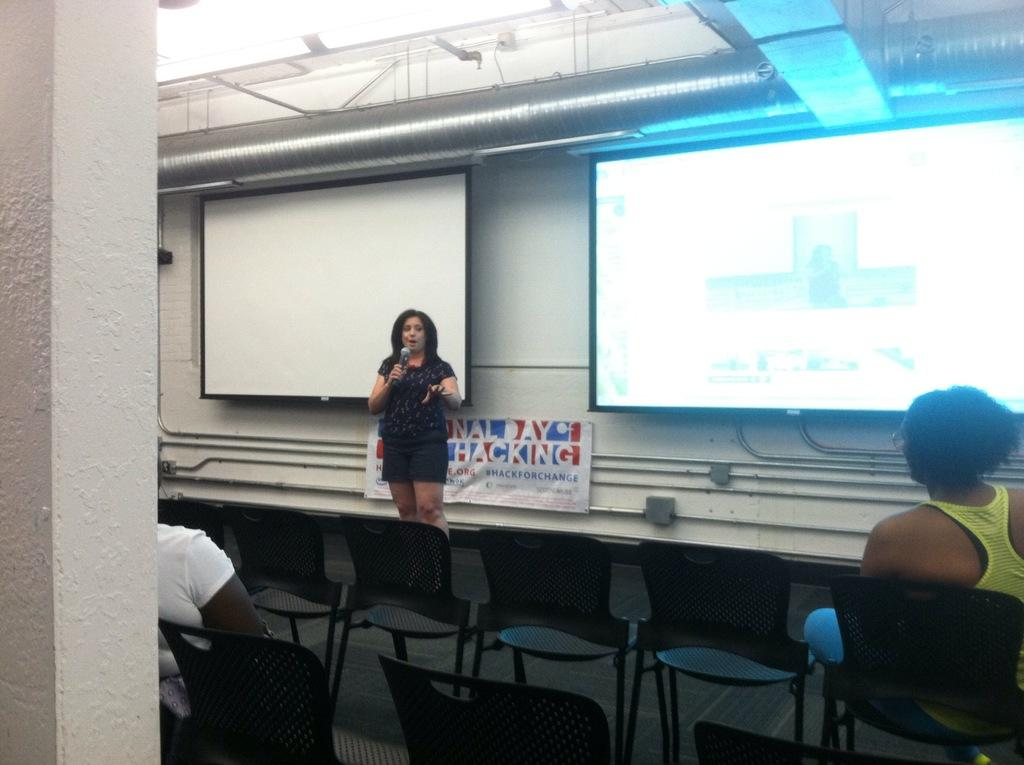How many people are present in the image? There are three people in the image. What positions are the people in? Two of the people are sitting, and one person is standing. What can be seen on the wall in the image? There is a screen on the wall. What type of screen is visible in the image? There is a projector's screen in the image. Can you tell me how many bridges are visible in the image? There are no bridges present in the image. What time of day is it in the image? The provided facts do not give any information about the time of day in the image. 